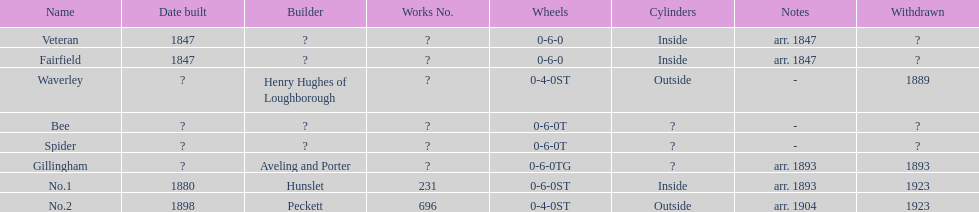What appellation is noted post spider? Gillingham. 